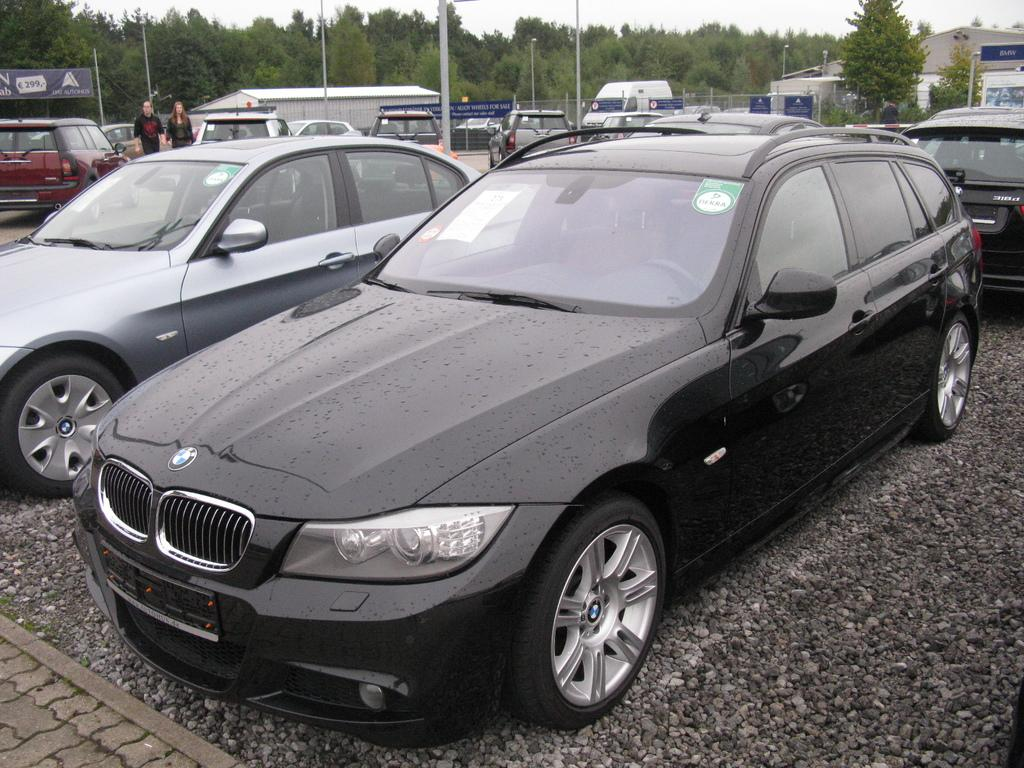What color is the car on the road in the image? The car on the road is black. What is happening with the cars on the left side of the image? The cars on the left side are parked. How many people are on the left side of the image? There are 2 persons on the left side. What can be seen at the back side of the image? There are trees at the back side of the image. Is there a net visible at the seashore in the image? There is no seashore or net present in the image; it features a road with parked cars and trees in the background. 